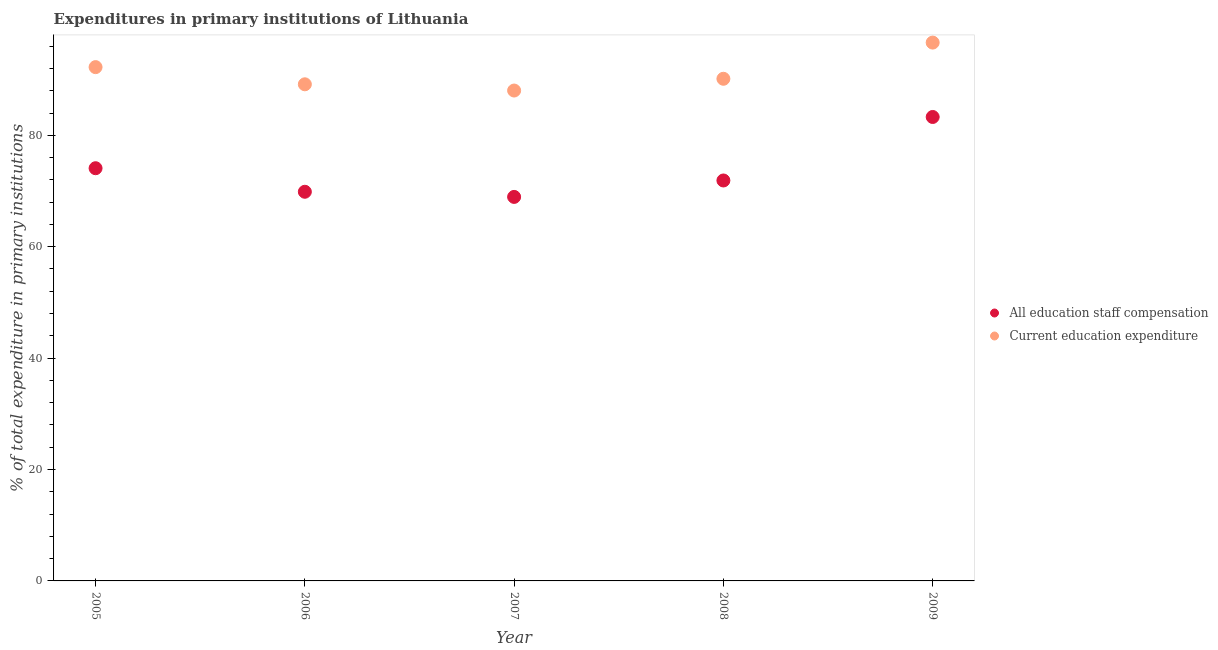How many different coloured dotlines are there?
Your response must be concise. 2. Is the number of dotlines equal to the number of legend labels?
Offer a very short reply. Yes. What is the expenditure in staff compensation in 2009?
Offer a very short reply. 83.29. Across all years, what is the maximum expenditure in staff compensation?
Give a very brief answer. 83.29. Across all years, what is the minimum expenditure in education?
Provide a succinct answer. 88.04. What is the total expenditure in staff compensation in the graph?
Provide a succinct answer. 368.07. What is the difference between the expenditure in staff compensation in 2007 and that in 2009?
Give a very brief answer. -14.35. What is the difference between the expenditure in education in 2006 and the expenditure in staff compensation in 2009?
Ensure brevity in your answer.  5.87. What is the average expenditure in staff compensation per year?
Keep it short and to the point. 73.61. In the year 2006, what is the difference between the expenditure in staff compensation and expenditure in education?
Your response must be concise. -19.29. In how many years, is the expenditure in education greater than 72 %?
Offer a terse response. 5. What is the ratio of the expenditure in staff compensation in 2005 to that in 2008?
Give a very brief answer. 1.03. Is the expenditure in education in 2007 less than that in 2008?
Your answer should be very brief. Yes. What is the difference between the highest and the second highest expenditure in staff compensation?
Make the answer very short. 9.2. What is the difference between the highest and the lowest expenditure in education?
Provide a succinct answer. 8.61. In how many years, is the expenditure in education greater than the average expenditure in education taken over all years?
Offer a terse response. 2. Does the expenditure in staff compensation monotonically increase over the years?
Your answer should be very brief. No. Is the expenditure in education strictly greater than the expenditure in staff compensation over the years?
Ensure brevity in your answer.  Yes. Is the expenditure in staff compensation strictly less than the expenditure in education over the years?
Give a very brief answer. Yes. What is the difference between two consecutive major ticks on the Y-axis?
Your response must be concise. 20. Does the graph contain any zero values?
Give a very brief answer. No. Does the graph contain grids?
Provide a succinct answer. No. How are the legend labels stacked?
Make the answer very short. Vertical. What is the title of the graph?
Ensure brevity in your answer.  Expenditures in primary institutions of Lithuania. What is the label or title of the X-axis?
Keep it short and to the point. Year. What is the label or title of the Y-axis?
Keep it short and to the point. % of total expenditure in primary institutions. What is the % of total expenditure in primary institutions in All education staff compensation in 2005?
Your answer should be very brief. 74.09. What is the % of total expenditure in primary institutions of Current education expenditure in 2005?
Offer a terse response. 92.24. What is the % of total expenditure in primary institutions of All education staff compensation in 2006?
Make the answer very short. 69.86. What is the % of total expenditure in primary institutions in Current education expenditure in 2006?
Keep it short and to the point. 89.16. What is the % of total expenditure in primary institutions of All education staff compensation in 2007?
Keep it short and to the point. 68.94. What is the % of total expenditure in primary institutions of Current education expenditure in 2007?
Ensure brevity in your answer.  88.04. What is the % of total expenditure in primary institutions in All education staff compensation in 2008?
Provide a succinct answer. 71.89. What is the % of total expenditure in primary institutions of Current education expenditure in 2008?
Provide a short and direct response. 90.15. What is the % of total expenditure in primary institutions in All education staff compensation in 2009?
Offer a terse response. 83.29. What is the % of total expenditure in primary institutions of Current education expenditure in 2009?
Ensure brevity in your answer.  96.64. Across all years, what is the maximum % of total expenditure in primary institutions in All education staff compensation?
Your answer should be compact. 83.29. Across all years, what is the maximum % of total expenditure in primary institutions in Current education expenditure?
Offer a very short reply. 96.64. Across all years, what is the minimum % of total expenditure in primary institutions of All education staff compensation?
Offer a very short reply. 68.94. Across all years, what is the minimum % of total expenditure in primary institutions in Current education expenditure?
Your response must be concise. 88.04. What is the total % of total expenditure in primary institutions of All education staff compensation in the graph?
Provide a succinct answer. 368.07. What is the total % of total expenditure in primary institutions in Current education expenditure in the graph?
Your answer should be very brief. 456.22. What is the difference between the % of total expenditure in primary institutions in All education staff compensation in 2005 and that in 2006?
Give a very brief answer. 4.23. What is the difference between the % of total expenditure in primary institutions of Current education expenditure in 2005 and that in 2006?
Your answer should be compact. 3.08. What is the difference between the % of total expenditure in primary institutions of All education staff compensation in 2005 and that in 2007?
Make the answer very short. 5.15. What is the difference between the % of total expenditure in primary institutions in Current education expenditure in 2005 and that in 2007?
Offer a terse response. 4.2. What is the difference between the % of total expenditure in primary institutions in All education staff compensation in 2005 and that in 2008?
Your answer should be very brief. 2.2. What is the difference between the % of total expenditure in primary institutions of Current education expenditure in 2005 and that in 2008?
Keep it short and to the point. 2.09. What is the difference between the % of total expenditure in primary institutions in All education staff compensation in 2005 and that in 2009?
Provide a short and direct response. -9.2. What is the difference between the % of total expenditure in primary institutions in Current education expenditure in 2005 and that in 2009?
Provide a succinct answer. -4.4. What is the difference between the % of total expenditure in primary institutions in All education staff compensation in 2006 and that in 2007?
Make the answer very short. 0.92. What is the difference between the % of total expenditure in primary institutions of Current education expenditure in 2006 and that in 2007?
Keep it short and to the point. 1.12. What is the difference between the % of total expenditure in primary institutions of All education staff compensation in 2006 and that in 2008?
Ensure brevity in your answer.  -2.03. What is the difference between the % of total expenditure in primary institutions of Current education expenditure in 2006 and that in 2008?
Your answer should be compact. -0.99. What is the difference between the % of total expenditure in primary institutions in All education staff compensation in 2006 and that in 2009?
Your answer should be compact. -13.43. What is the difference between the % of total expenditure in primary institutions of Current education expenditure in 2006 and that in 2009?
Keep it short and to the point. -7.49. What is the difference between the % of total expenditure in primary institutions in All education staff compensation in 2007 and that in 2008?
Make the answer very short. -2.95. What is the difference between the % of total expenditure in primary institutions of Current education expenditure in 2007 and that in 2008?
Your answer should be very brief. -2.11. What is the difference between the % of total expenditure in primary institutions in All education staff compensation in 2007 and that in 2009?
Keep it short and to the point. -14.35. What is the difference between the % of total expenditure in primary institutions in Current education expenditure in 2007 and that in 2009?
Give a very brief answer. -8.61. What is the difference between the % of total expenditure in primary institutions in All education staff compensation in 2008 and that in 2009?
Offer a very short reply. -11.4. What is the difference between the % of total expenditure in primary institutions of Current education expenditure in 2008 and that in 2009?
Offer a terse response. -6.5. What is the difference between the % of total expenditure in primary institutions in All education staff compensation in 2005 and the % of total expenditure in primary institutions in Current education expenditure in 2006?
Provide a succinct answer. -15.07. What is the difference between the % of total expenditure in primary institutions of All education staff compensation in 2005 and the % of total expenditure in primary institutions of Current education expenditure in 2007?
Keep it short and to the point. -13.95. What is the difference between the % of total expenditure in primary institutions of All education staff compensation in 2005 and the % of total expenditure in primary institutions of Current education expenditure in 2008?
Your response must be concise. -16.06. What is the difference between the % of total expenditure in primary institutions in All education staff compensation in 2005 and the % of total expenditure in primary institutions in Current education expenditure in 2009?
Offer a very short reply. -22.55. What is the difference between the % of total expenditure in primary institutions of All education staff compensation in 2006 and the % of total expenditure in primary institutions of Current education expenditure in 2007?
Your answer should be compact. -18.17. What is the difference between the % of total expenditure in primary institutions of All education staff compensation in 2006 and the % of total expenditure in primary institutions of Current education expenditure in 2008?
Offer a terse response. -20.28. What is the difference between the % of total expenditure in primary institutions in All education staff compensation in 2006 and the % of total expenditure in primary institutions in Current education expenditure in 2009?
Offer a terse response. -26.78. What is the difference between the % of total expenditure in primary institutions of All education staff compensation in 2007 and the % of total expenditure in primary institutions of Current education expenditure in 2008?
Provide a succinct answer. -21.21. What is the difference between the % of total expenditure in primary institutions of All education staff compensation in 2007 and the % of total expenditure in primary institutions of Current education expenditure in 2009?
Keep it short and to the point. -27.7. What is the difference between the % of total expenditure in primary institutions of All education staff compensation in 2008 and the % of total expenditure in primary institutions of Current education expenditure in 2009?
Offer a very short reply. -24.75. What is the average % of total expenditure in primary institutions of All education staff compensation per year?
Your answer should be very brief. 73.61. What is the average % of total expenditure in primary institutions of Current education expenditure per year?
Ensure brevity in your answer.  91.24. In the year 2005, what is the difference between the % of total expenditure in primary institutions in All education staff compensation and % of total expenditure in primary institutions in Current education expenditure?
Ensure brevity in your answer.  -18.15. In the year 2006, what is the difference between the % of total expenditure in primary institutions of All education staff compensation and % of total expenditure in primary institutions of Current education expenditure?
Make the answer very short. -19.29. In the year 2007, what is the difference between the % of total expenditure in primary institutions in All education staff compensation and % of total expenditure in primary institutions in Current education expenditure?
Offer a very short reply. -19.1. In the year 2008, what is the difference between the % of total expenditure in primary institutions of All education staff compensation and % of total expenditure in primary institutions of Current education expenditure?
Ensure brevity in your answer.  -18.26. In the year 2009, what is the difference between the % of total expenditure in primary institutions of All education staff compensation and % of total expenditure in primary institutions of Current education expenditure?
Provide a succinct answer. -13.35. What is the ratio of the % of total expenditure in primary institutions of All education staff compensation in 2005 to that in 2006?
Offer a terse response. 1.06. What is the ratio of the % of total expenditure in primary institutions in Current education expenditure in 2005 to that in 2006?
Your response must be concise. 1.03. What is the ratio of the % of total expenditure in primary institutions in All education staff compensation in 2005 to that in 2007?
Keep it short and to the point. 1.07. What is the ratio of the % of total expenditure in primary institutions in Current education expenditure in 2005 to that in 2007?
Keep it short and to the point. 1.05. What is the ratio of the % of total expenditure in primary institutions of All education staff compensation in 2005 to that in 2008?
Keep it short and to the point. 1.03. What is the ratio of the % of total expenditure in primary institutions in Current education expenditure in 2005 to that in 2008?
Offer a terse response. 1.02. What is the ratio of the % of total expenditure in primary institutions of All education staff compensation in 2005 to that in 2009?
Keep it short and to the point. 0.89. What is the ratio of the % of total expenditure in primary institutions of Current education expenditure in 2005 to that in 2009?
Your answer should be compact. 0.95. What is the ratio of the % of total expenditure in primary institutions of All education staff compensation in 2006 to that in 2007?
Your answer should be compact. 1.01. What is the ratio of the % of total expenditure in primary institutions of Current education expenditure in 2006 to that in 2007?
Offer a very short reply. 1.01. What is the ratio of the % of total expenditure in primary institutions of All education staff compensation in 2006 to that in 2008?
Your response must be concise. 0.97. What is the ratio of the % of total expenditure in primary institutions in Current education expenditure in 2006 to that in 2008?
Provide a succinct answer. 0.99. What is the ratio of the % of total expenditure in primary institutions of All education staff compensation in 2006 to that in 2009?
Make the answer very short. 0.84. What is the ratio of the % of total expenditure in primary institutions of Current education expenditure in 2006 to that in 2009?
Offer a very short reply. 0.92. What is the ratio of the % of total expenditure in primary institutions in Current education expenditure in 2007 to that in 2008?
Give a very brief answer. 0.98. What is the ratio of the % of total expenditure in primary institutions of All education staff compensation in 2007 to that in 2009?
Provide a succinct answer. 0.83. What is the ratio of the % of total expenditure in primary institutions in Current education expenditure in 2007 to that in 2009?
Offer a terse response. 0.91. What is the ratio of the % of total expenditure in primary institutions in All education staff compensation in 2008 to that in 2009?
Provide a succinct answer. 0.86. What is the ratio of the % of total expenditure in primary institutions of Current education expenditure in 2008 to that in 2009?
Your answer should be compact. 0.93. What is the difference between the highest and the second highest % of total expenditure in primary institutions of All education staff compensation?
Ensure brevity in your answer.  9.2. What is the difference between the highest and the second highest % of total expenditure in primary institutions of Current education expenditure?
Offer a terse response. 4.4. What is the difference between the highest and the lowest % of total expenditure in primary institutions in All education staff compensation?
Your answer should be very brief. 14.35. What is the difference between the highest and the lowest % of total expenditure in primary institutions of Current education expenditure?
Offer a terse response. 8.61. 